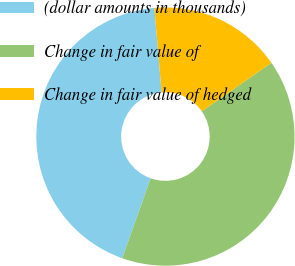Convert chart to OTSL. <chart><loc_0><loc_0><loc_500><loc_500><pie_chart><fcel>(dollar amounts in thousands)<fcel>Change in fair value of<fcel>Change in fair value of hedged<nl><fcel>43.21%<fcel>40.11%<fcel>16.69%<nl></chart> 